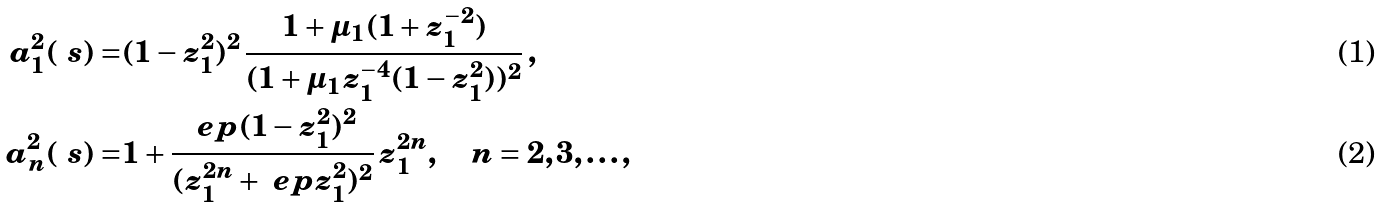Convert formula to latex. <formula><loc_0><loc_0><loc_500><loc_500>a ^ { 2 } _ { 1 } ( \ s ) = & ( 1 - z _ { 1 } ^ { 2 } ) ^ { 2 } \, \frac { 1 + \mu _ { 1 } ( 1 + z _ { 1 } ^ { - 2 } ) } { ( 1 + \mu _ { 1 } z _ { 1 } ^ { - 4 } ( 1 - z _ { 1 } ^ { 2 } ) ) ^ { 2 } } \, , \\ a ^ { 2 } _ { n } ( \ s ) = & 1 + \frac { \ e p ( 1 - z _ { 1 } ^ { 2 } ) ^ { 2 } } { ( z _ { 1 } ^ { 2 n } + \ e p z _ { 1 } ^ { 2 } ) ^ { 2 } } \, z _ { 1 } ^ { 2 n } , \quad n = 2 , 3 , \dots ,</formula> 